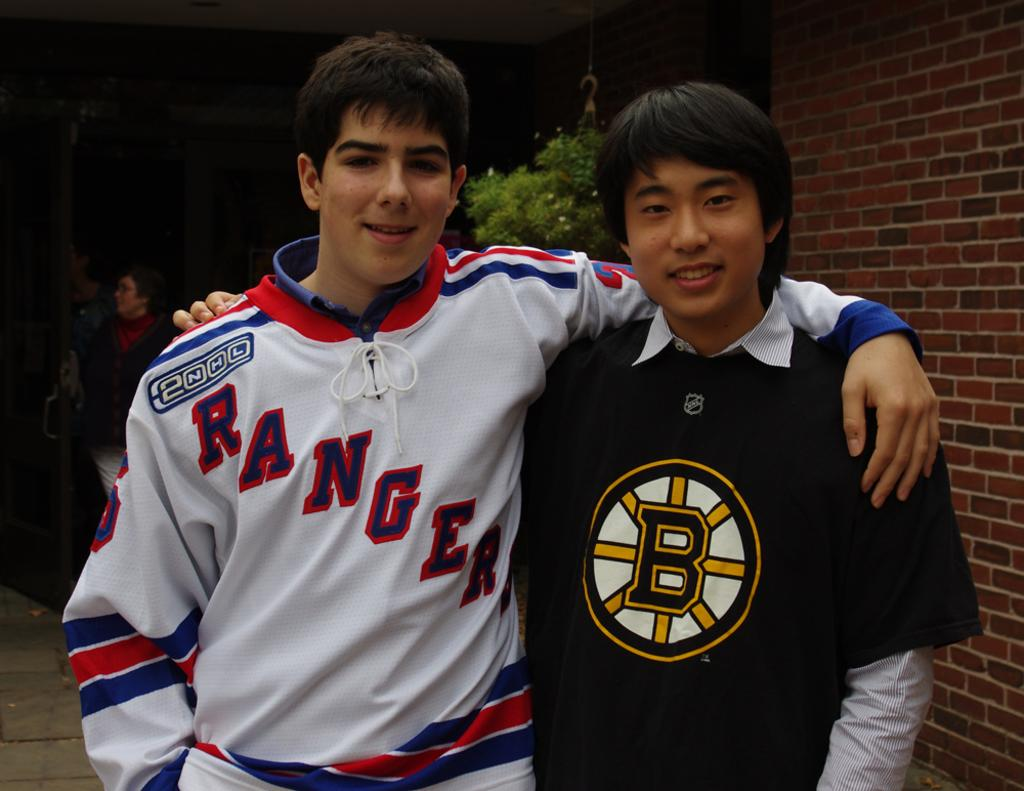<image>
Render a clear and concise summary of the photo. A young man in a Rangers jersey poses for a photo. 